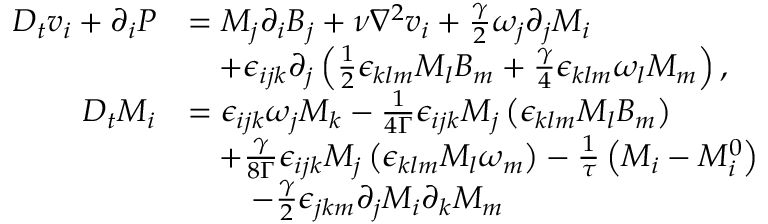<formula> <loc_0><loc_0><loc_500><loc_500>\begin{array} { r l } { D _ { t } v _ { i } + \partial _ { i } P } & { = M _ { j } \partial _ { i } B _ { j } + \nu \nabla ^ { 2 } v _ { i } + \frac { \gamma } { 2 } \omega _ { j } \partial _ { j } M _ { i } } \\ & { \quad + \epsilon _ { i j k } \partial _ { j } \left ( \frac { 1 } { 2 } \epsilon _ { k l m } M _ { l } B _ { m } + \frac { \gamma } { 4 } \epsilon _ { k l m } \omega _ { l } M _ { m } \right ) , } \\ { D _ { t } M _ { i } } & { = \epsilon _ { i j k } \omega _ { j } M _ { k } - \frac { 1 } { 4 \Gamma } \epsilon _ { i j k } M _ { j } \left ( \epsilon _ { k l m } M _ { l } B _ { m } \right ) } \\ & { \quad + \frac { \gamma } { 8 \Gamma } \epsilon _ { i j k } M _ { j } \left ( \epsilon _ { k l m } M _ { l } \omega _ { m } \right ) - \frac { 1 } { \tau } \left ( M _ { i } - M _ { i } ^ { 0 } \right ) } \\ & { \quad - \frac { \gamma } { 2 } \epsilon _ { j k m } \partial _ { j } M _ { i } \partial _ { k } M _ { m } } \end{array}</formula> 